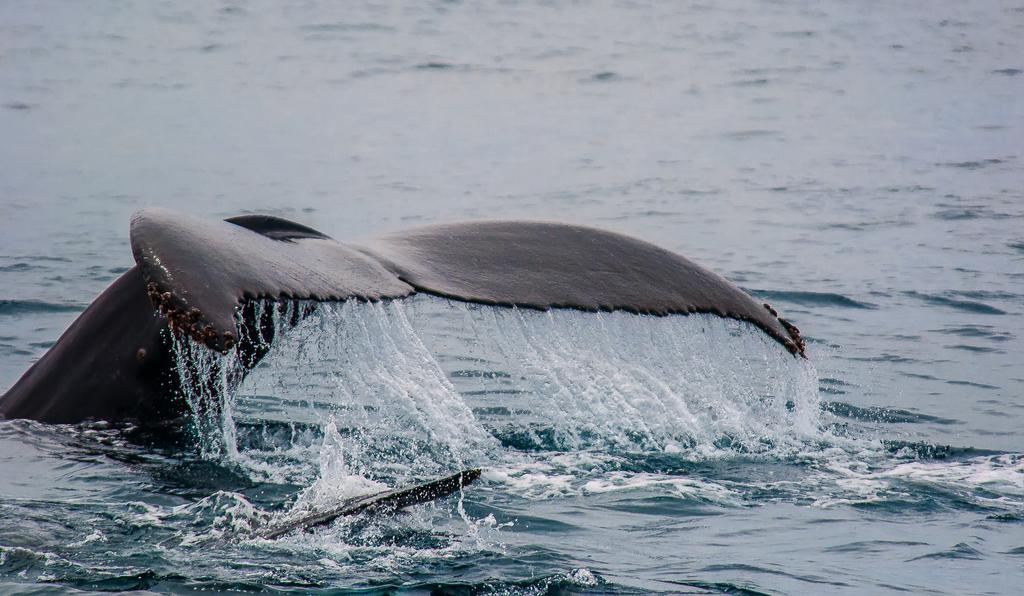What is the main subject of the image? The main subject of the image is a whale tail in the water. Can you describe the location of the whale tail in the image? The whale tail is in the water in the image. What color is the cream used to paint the whale's tail in the image? There is no cream or painting activity depicted in the image; it simply shows a whale tail in the water. 